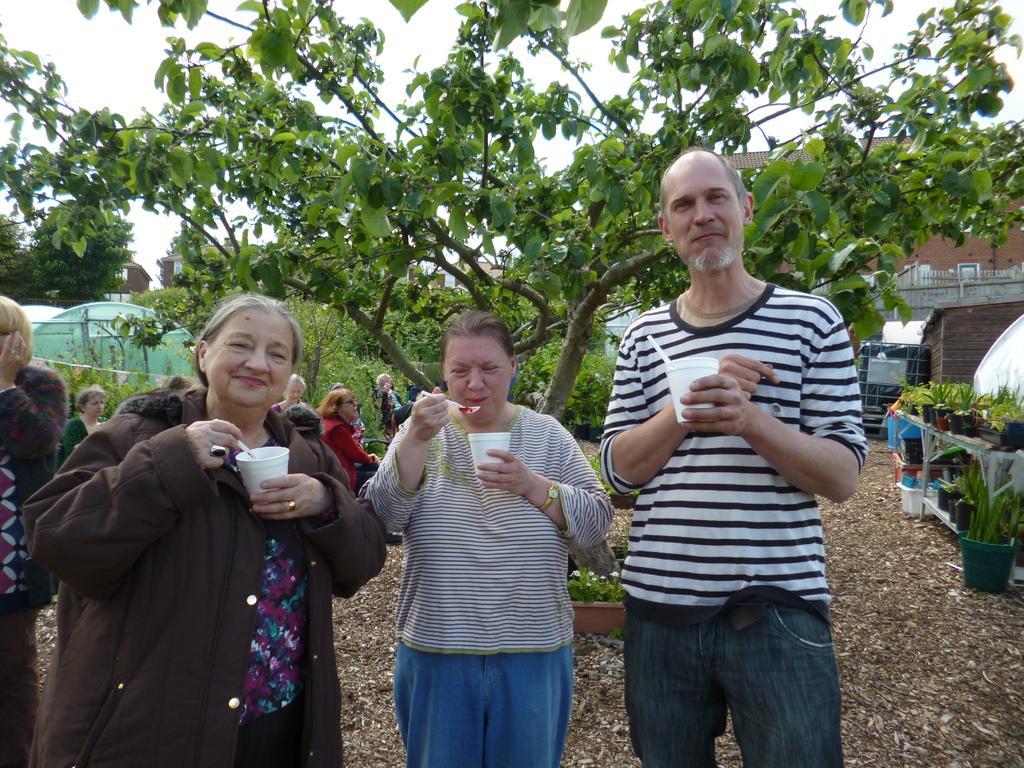In one or two sentences, can you explain what this image depicts? In the image in the center, we can see three persons are standing and they are holding glasses. And we can see they are smiling, which we can see on their faces. In the background, we can see the sky, clouds, trees, plant pots, buildings, plants, few people are sitting etc. 